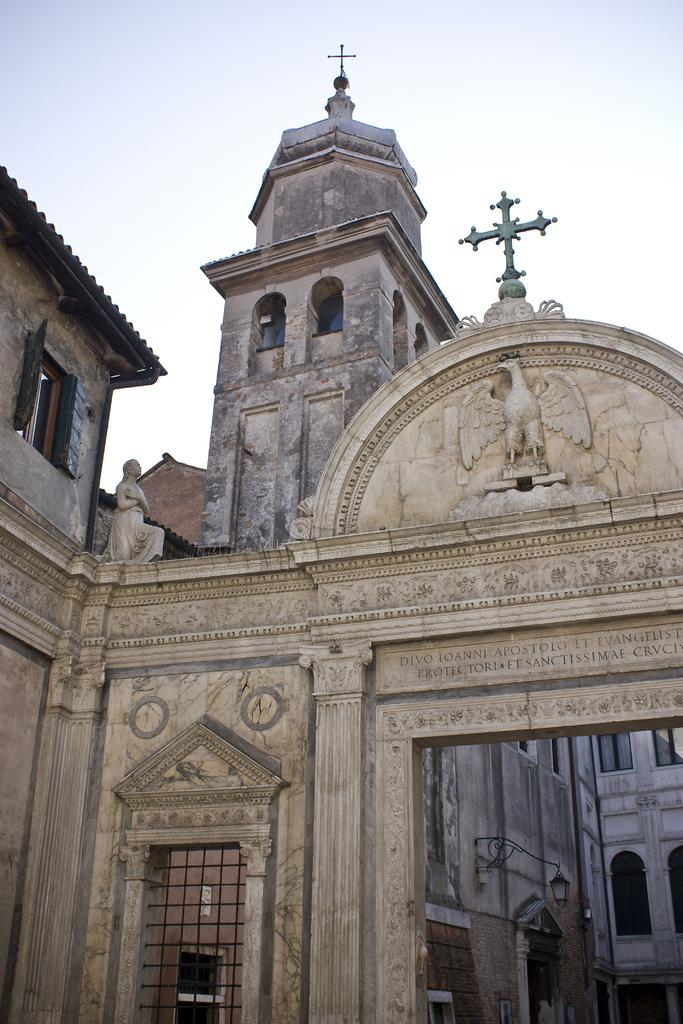What type of structure is present in the image? There is a building in the image. What part of the natural environment is visible in the image? The sky is visible in the image. What type of celery is being used to protest in the image? There is no celery or protest present in the image. 